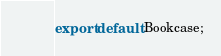<code> <loc_0><loc_0><loc_500><loc_500><_TypeScript_>export default Bookcase;
</code> 